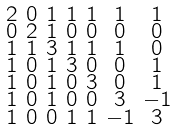<formula> <loc_0><loc_0><loc_500><loc_500>\begin{smallmatrix} 2 & 0 & 1 & 1 & 1 & 1 & 1 \\ 0 & 2 & 1 & 0 & 0 & 0 & 0 \\ 1 & 1 & 3 & 1 & 1 & 1 & 0 \\ 1 & 0 & 1 & 3 & 0 & 0 & 1 \\ 1 & 0 & 1 & 0 & 3 & 0 & 1 \\ 1 & 0 & 1 & 0 & 0 & 3 & - 1 \\ 1 & 0 & 0 & 1 & 1 & - 1 & 3 \end{smallmatrix}</formula> 